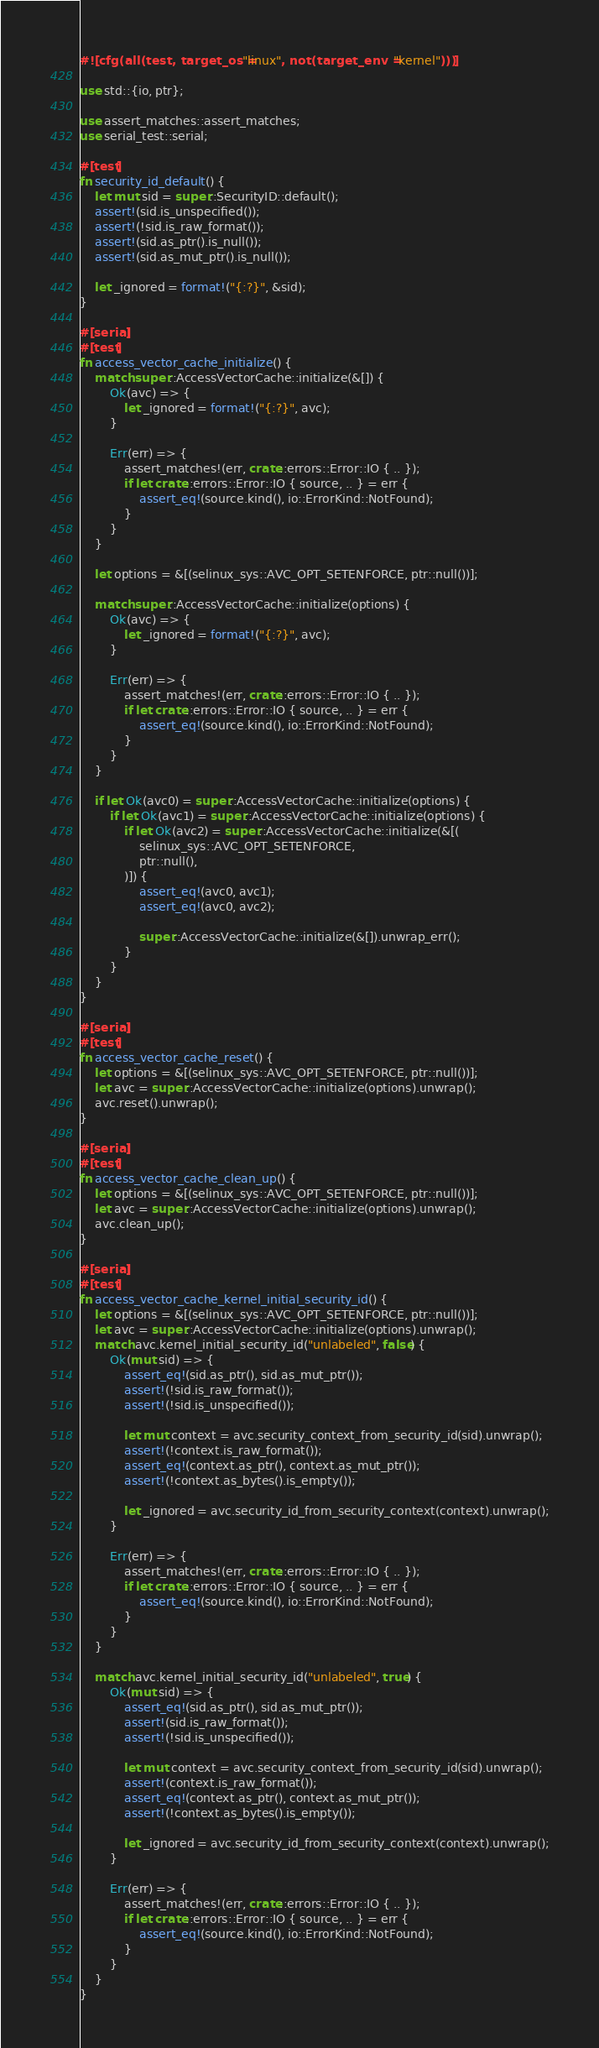<code> <loc_0><loc_0><loc_500><loc_500><_Rust_>#![cfg(all(test, target_os = "linux", not(target_env = "kernel")))]

use std::{io, ptr};

use assert_matches::assert_matches;
use serial_test::serial;

#[test]
fn security_id_default() {
    let mut sid = super::SecurityID::default();
    assert!(sid.is_unspecified());
    assert!(!sid.is_raw_format());
    assert!(sid.as_ptr().is_null());
    assert!(sid.as_mut_ptr().is_null());

    let _ignored = format!("{:?}", &sid);
}

#[serial]
#[test]
fn access_vector_cache_initialize() {
    match super::AccessVectorCache::initialize(&[]) {
        Ok(avc) => {
            let _ignored = format!("{:?}", avc);
        }

        Err(err) => {
            assert_matches!(err, crate::errors::Error::IO { .. });
            if let crate::errors::Error::IO { source, .. } = err {
                assert_eq!(source.kind(), io::ErrorKind::NotFound);
            }
        }
    }

    let options = &[(selinux_sys::AVC_OPT_SETENFORCE, ptr::null())];

    match super::AccessVectorCache::initialize(options) {
        Ok(avc) => {
            let _ignored = format!("{:?}", avc);
        }

        Err(err) => {
            assert_matches!(err, crate::errors::Error::IO { .. });
            if let crate::errors::Error::IO { source, .. } = err {
                assert_eq!(source.kind(), io::ErrorKind::NotFound);
            }
        }
    }

    if let Ok(avc0) = super::AccessVectorCache::initialize(options) {
        if let Ok(avc1) = super::AccessVectorCache::initialize(options) {
            if let Ok(avc2) = super::AccessVectorCache::initialize(&[(
                selinux_sys::AVC_OPT_SETENFORCE,
                ptr::null(),
            )]) {
                assert_eq!(avc0, avc1);
                assert_eq!(avc0, avc2);

                super::AccessVectorCache::initialize(&[]).unwrap_err();
            }
        }
    }
}

#[serial]
#[test]
fn access_vector_cache_reset() {
    let options = &[(selinux_sys::AVC_OPT_SETENFORCE, ptr::null())];
    let avc = super::AccessVectorCache::initialize(options).unwrap();
    avc.reset().unwrap();
}

#[serial]
#[test]
fn access_vector_cache_clean_up() {
    let options = &[(selinux_sys::AVC_OPT_SETENFORCE, ptr::null())];
    let avc = super::AccessVectorCache::initialize(options).unwrap();
    avc.clean_up();
}

#[serial]
#[test]
fn access_vector_cache_kernel_initial_security_id() {
    let options = &[(selinux_sys::AVC_OPT_SETENFORCE, ptr::null())];
    let avc = super::AccessVectorCache::initialize(options).unwrap();
    match avc.kernel_initial_security_id("unlabeled", false) {
        Ok(mut sid) => {
            assert_eq!(sid.as_ptr(), sid.as_mut_ptr());
            assert!(!sid.is_raw_format());
            assert!(!sid.is_unspecified());

            let mut context = avc.security_context_from_security_id(sid).unwrap();
            assert!(!context.is_raw_format());
            assert_eq!(context.as_ptr(), context.as_mut_ptr());
            assert!(!context.as_bytes().is_empty());

            let _ignored = avc.security_id_from_security_context(context).unwrap();
        }

        Err(err) => {
            assert_matches!(err, crate::errors::Error::IO { .. });
            if let crate::errors::Error::IO { source, .. } = err {
                assert_eq!(source.kind(), io::ErrorKind::NotFound);
            }
        }
    }

    match avc.kernel_initial_security_id("unlabeled", true) {
        Ok(mut sid) => {
            assert_eq!(sid.as_ptr(), sid.as_mut_ptr());
            assert!(sid.is_raw_format());
            assert!(!sid.is_unspecified());

            let mut context = avc.security_context_from_security_id(sid).unwrap();
            assert!(context.is_raw_format());
            assert_eq!(context.as_ptr(), context.as_mut_ptr());
            assert!(!context.as_bytes().is_empty());

            let _ignored = avc.security_id_from_security_context(context).unwrap();
        }

        Err(err) => {
            assert_matches!(err, crate::errors::Error::IO { .. });
            if let crate::errors::Error::IO { source, .. } = err {
                assert_eq!(source.kind(), io::ErrorKind::NotFound);
            }
        }
    }
}
</code> 